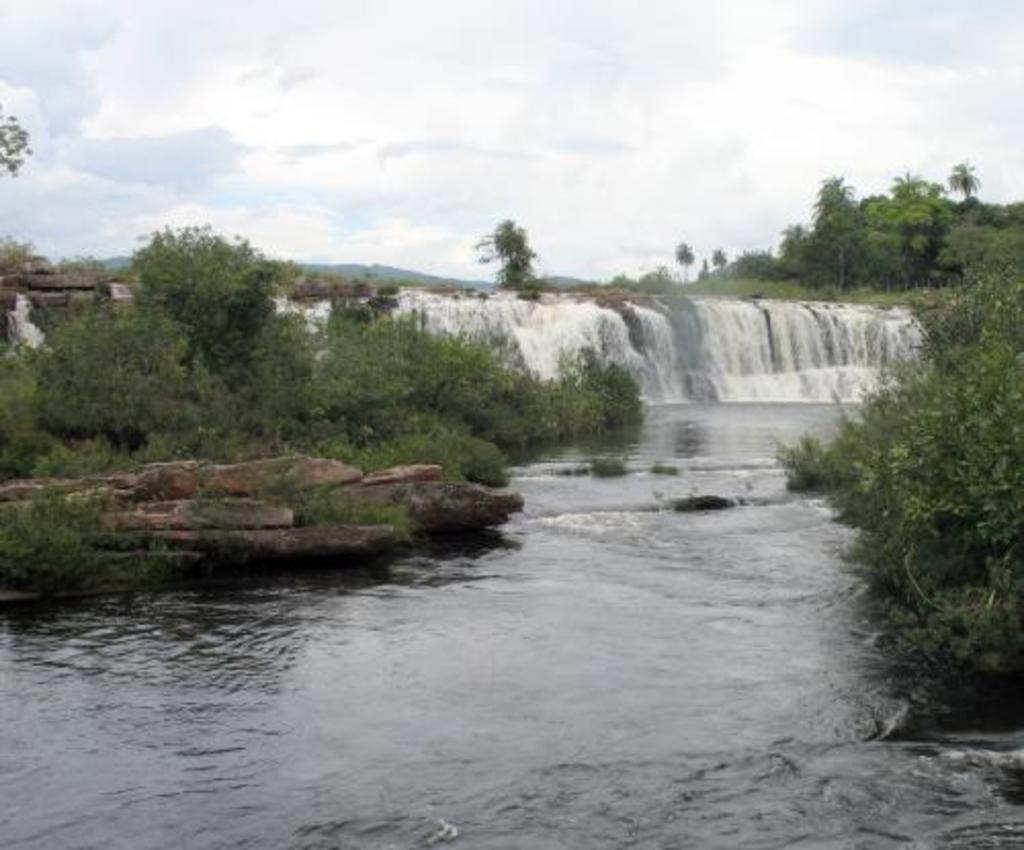What is the primary element visible in the image? There is water in the image. What type of vegetation can be seen in the image? There are trees with green color in the image. What colors are present in the sky in the image? The sky is visible in the image, with white and blue colors. Can you see a toad climbing a rose in the image? There is no toad or rose present in the image. 